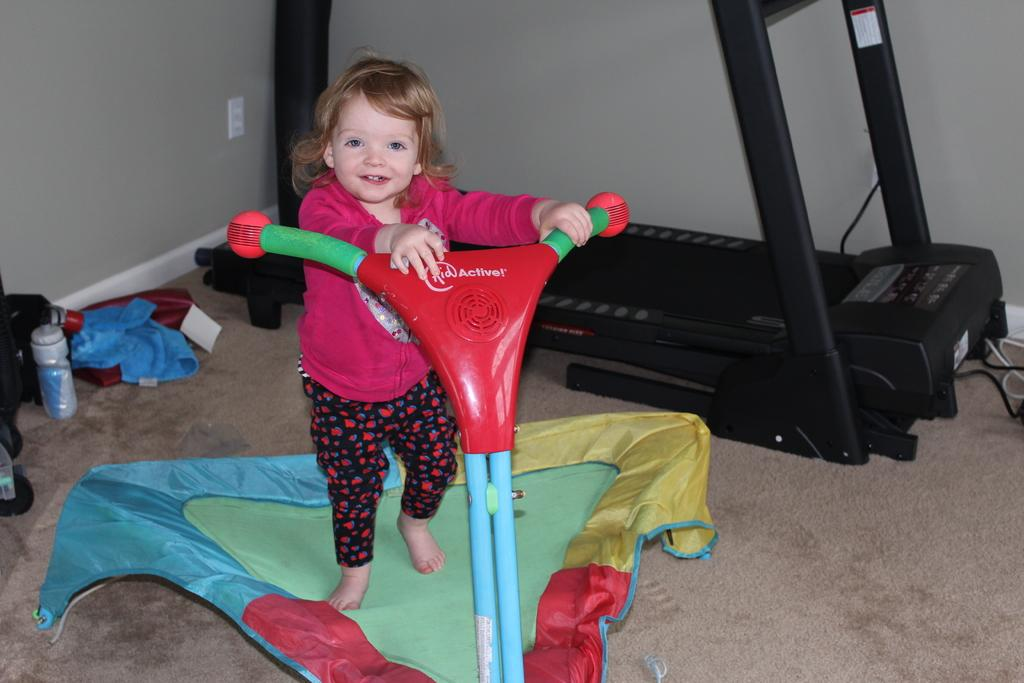What is the main subject in the foreground of the image? There is a kid in the foreground of the image. What is the kid riding in the image? The kid is on a toddler vehicle. Where is the toddler vehicle located in the image? The toddler vehicle is on the floor. What can be seen in the background of the image? There is a treadmill, clothes, and a bottle in the background of the image. Are there any other objects visible in the image? Yes, there are other objects on the left side of the image. What type of shoe is the kid wearing while riding the toddler vehicle? There is no shoe visible in the image, as the kid is on a toddler vehicle and not wearing any footwear. 